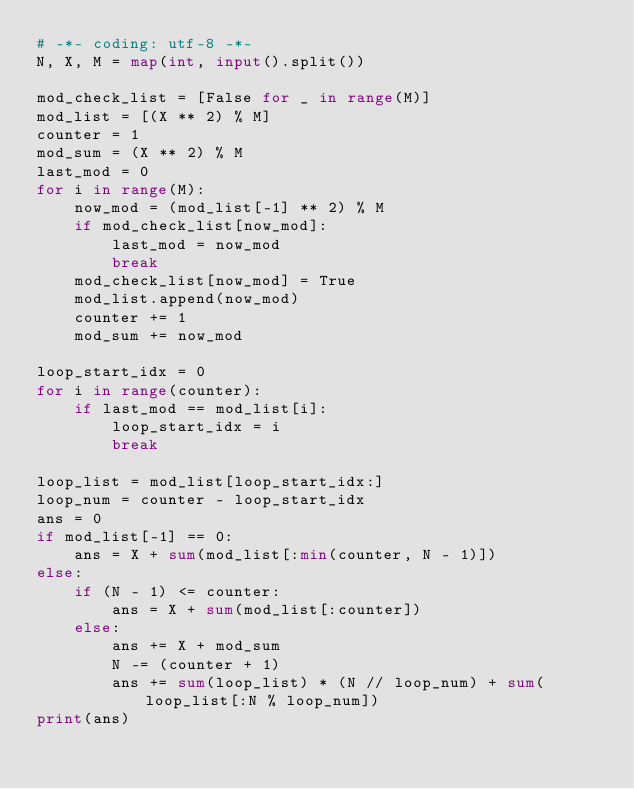Convert code to text. <code><loc_0><loc_0><loc_500><loc_500><_Python_># -*- coding: utf-8 -*-
N, X, M = map(int, input().split())

mod_check_list = [False for _ in range(M)]
mod_list = [(X ** 2) % M]
counter = 1
mod_sum = (X ** 2) % M
last_mod = 0
for i in range(M):
    now_mod = (mod_list[-1] ** 2) % M
    if mod_check_list[now_mod]:
        last_mod = now_mod
        break
    mod_check_list[now_mod] = True
    mod_list.append(now_mod)
    counter += 1
    mod_sum += now_mod

loop_start_idx = 0
for i in range(counter):
    if last_mod == mod_list[i]:
        loop_start_idx = i
        break

loop_list = mod_list[loop_start_idx:]
loop_num = counter - loop_start_idx
ans = 0
if mod_list[-1] == 0:
    ans = X + sum(mod_list[:min(counter, N - 1)])
else:
    if (N - 1) <= counter:
        ans = X + sum(mod_list[:counter])
    else:
        ans += X + mod_sum
        N -= (counter + 1)
        ans += sum(loop_list) * (N // loop_num) + sum(loop_list[:N % loop_num])
print(ans)</code> 